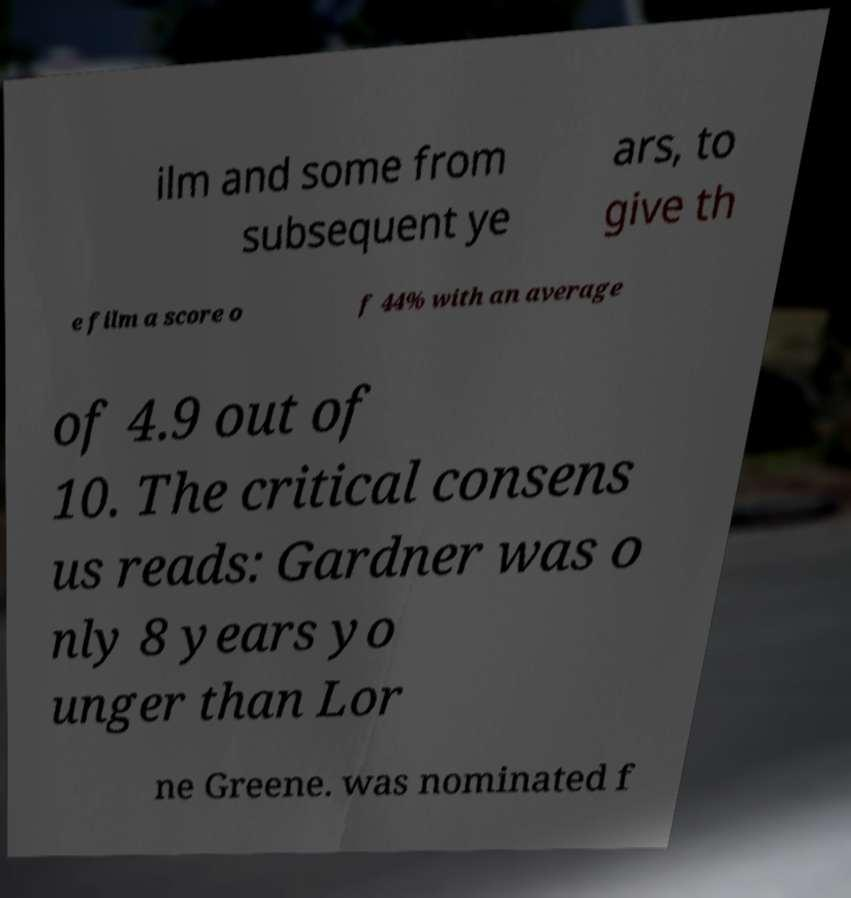Could you assist in decoding the text presented in this image and type it out clearly? ilm and some from subsequent ye ars, to give th e film a score o f 44% with an average of 4.9 out of 10. The critical consens us reads: Gardner was o nly 8 years yo unger than Lor ne Greene. was nominated f 